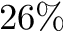Convert formula to latex. <formula><loc_0><loc_0><loc_500><loc_500>2 6 \%</formula> 